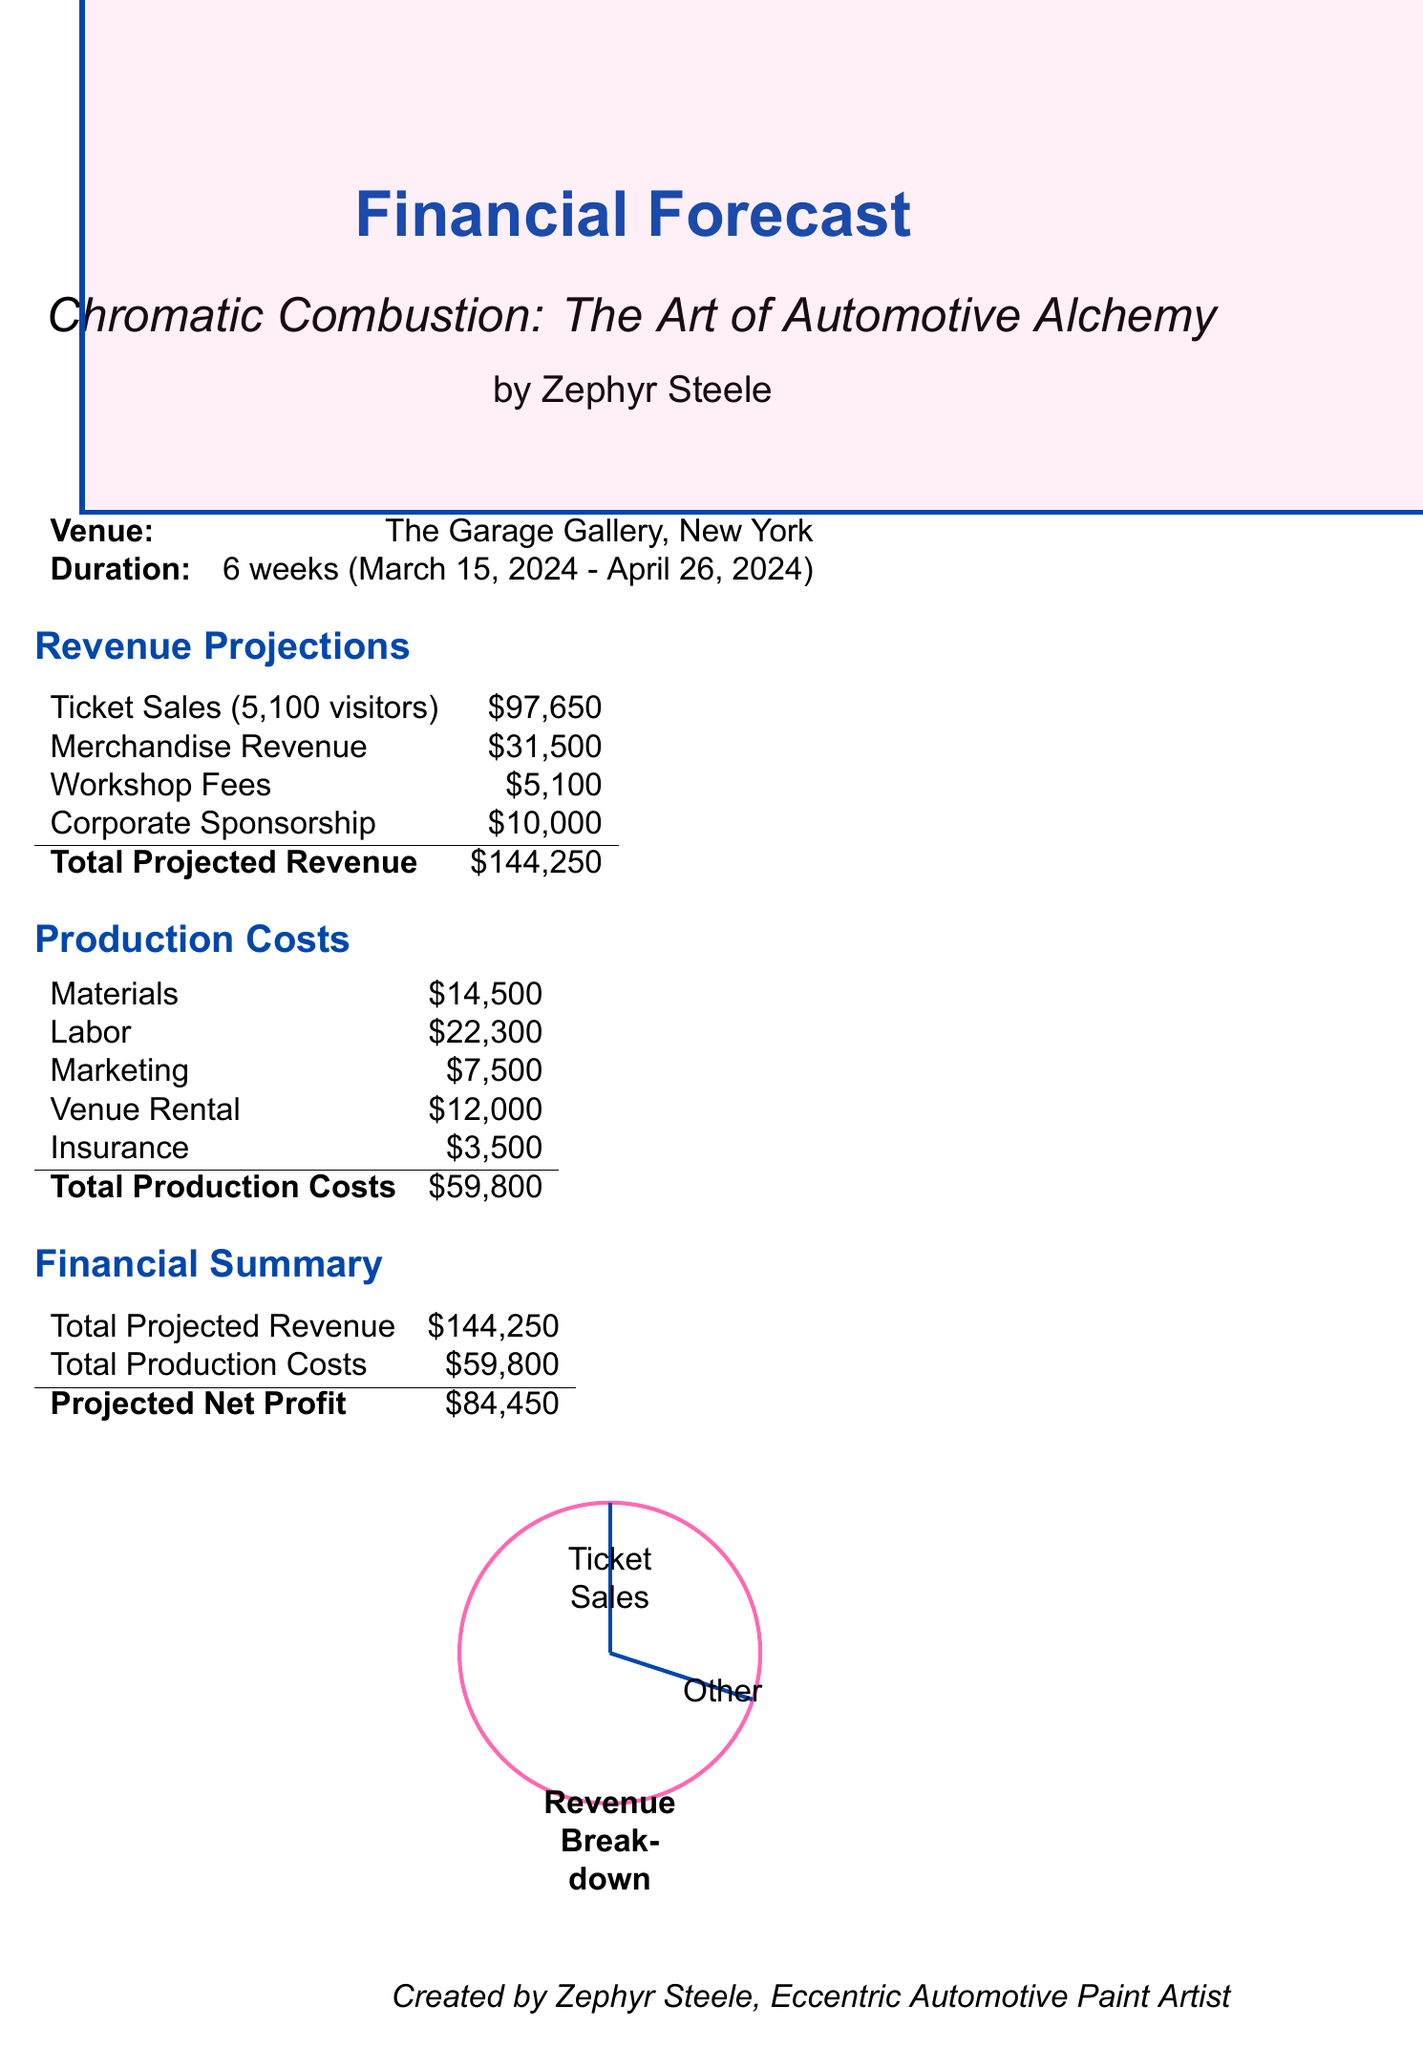What is the title of the exhibition? The title of the exhibition is specified in the document's introduction section.
Answer: Chromatic Combustion: The Art of Automotive Alchemy What is the artist's name? The artist's name is mentioned alongside the exhibition details.
Answer: Zephyr Steele What is the total projected revenue? The total projected revenue is calculated from various revenue sources mentioned in the document.
Answer: $144,250 How much is the artist fee? The artist fee is listed under the labor section of production costs.
Answer: $15,000 What is the ticket price for students? The document specifies different ticket prices for adults and students.
Answer: $15 How many workshops are planned? The document provides the number of workshops included in the additional revenue streams.
Answer: 4 What are the estimated weekly visitors? The estimated number of visitors per week is stated in the ticket sales projection.
Answer: 850 What is the total production costs? The total production costs can be derived from summing all costs outlined in the financial report.
Answer: $59,800 What is the corporate sponsorship amount? The amount for corporate sponsorship is specified within its dedicated section.
Answer: $10,000 What is the price of the Limited Edition Prints? The price of merchandise items is detailed in the merchandise revenue section.
Answer: $120 